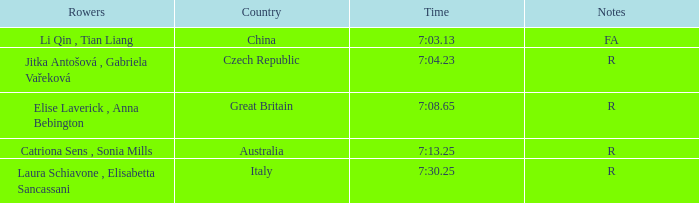What is the Rank of the Rowers with FA as Notes? 1.0. 